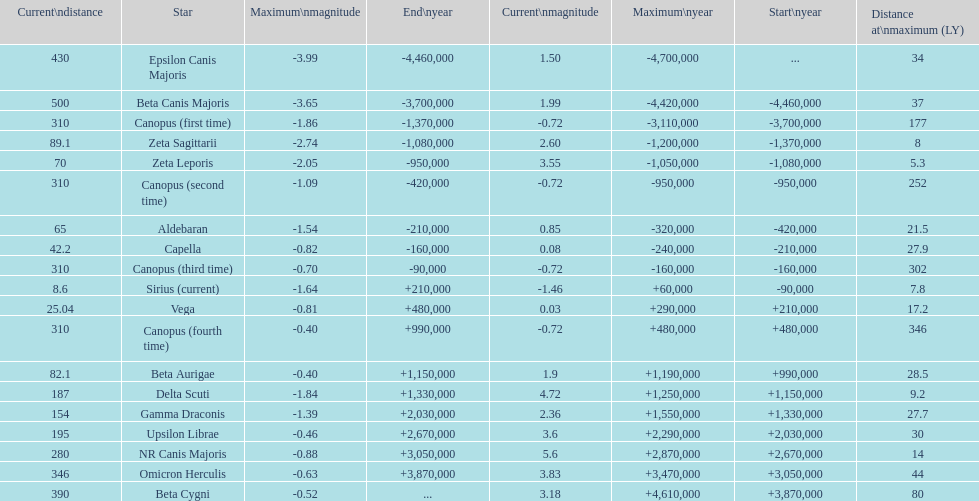How many stars have a current magnitude of at least 1.0? 11. 